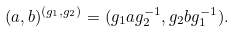Convert formula to latex. <formula><loc_0><loc_0><loc_500><loc_500>( a , b ) ^ { ( g _ { 1 } , g _ { 2 } ) } = ( g _ { 1 } a g _ { 2 } ^ { - 1 } , g _ { 2 } b g _ { 1 } ^ { - 1 } ) .</formula> 